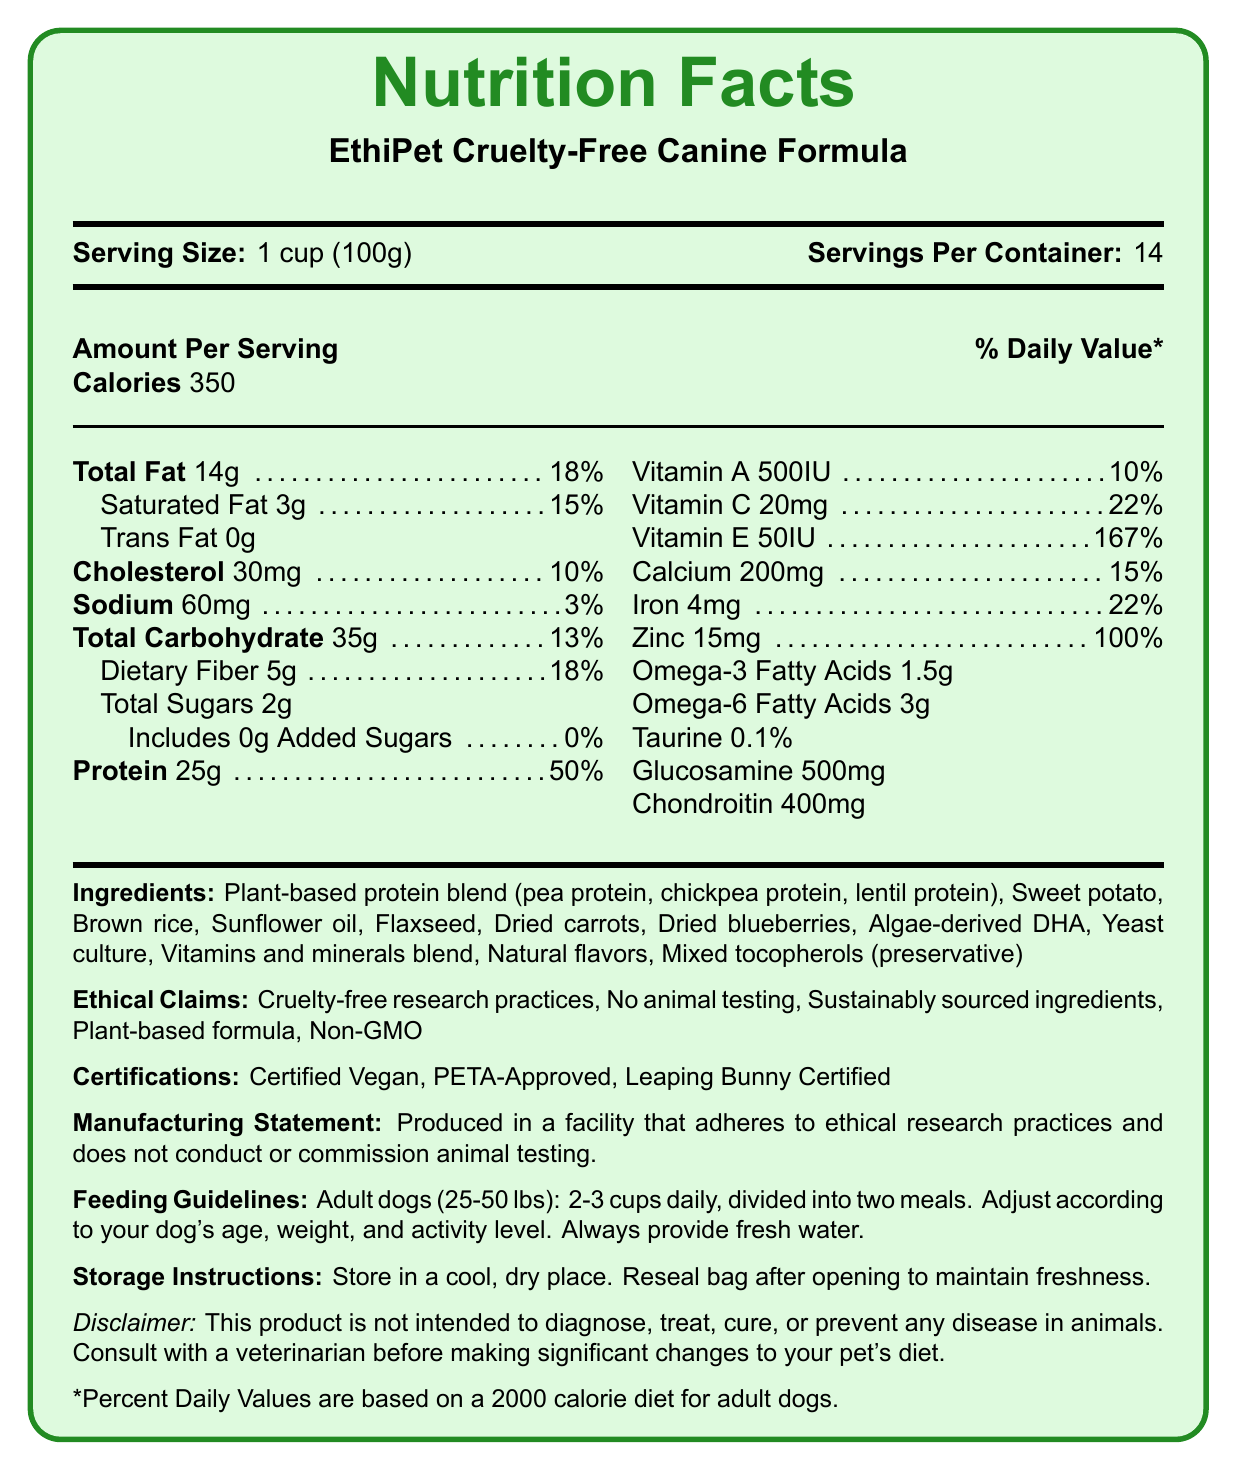what is the serving size for EthiPet Cruelty-Free Canine Formula? The document states that the serving size is 1 cup, which equals 100 grams.
Answer: 1 cup (100g) how many servings are there per container? The document specifies that there are 14 servings per container.
Answer: 14 what are the total calories per serving? The document lists the calories per serving as 350.
Answer: 350 what is the percentage of Daily Value for protein? The document indicates that the protein Daily Value percentage is 50%.
Answer: 50% what are the main ingredients of the product? The ingredients are listed in the document under the "Ingredients" section.
Answer: Plant-based protein blend, Sweet potato, Brown rice, Sunflower oil, Flaxseed, Dried carrots, Dried blueberries, Algae-derived DHA, Yeast culture, Vitamins and minerals blend, Natural flavors, Mixed tocopherols Which of the following are part of the ethical claims made by EthiPet Cruelty-Free Canine Formula? A. Cruelty-free research practices B. No animal testing C. Organic ingredients D. Sustainably sourced ingredients The document lists the ethical claims as: Cruelty-free research practices, No animal testing, Sustainably sourced ingredients, Plant-based formula, Non-GMO. Organic ingredients are not mentioned.
Answer: C. Organic ingredients How much Vitamin C does one serving provide? A. 10mg B. 15mg C. 20mg D. 25mg The document states that the Vitamin C content per serving is 20mg.
Answer: C. 20mg Is the product PETA-Approved? The document lists PETA-Approved under the certifications section.
Answer: Yes What does the document say regarding feeding guidelines for adult dogs? The feeding guidelines section in the document provides this information.
Answer: Adult dogs (25-50 lbs): 2-3 cups daily, divided into two meals. Adjust according to your dog's age, weight, and activity level. Always provide fresh water. Summarize the document. The document provides comprehensive information about the ingredients, nutritional content, ethical certifications, and usage instructions for EthiPet Cruelty-Free Canine Formula, an ethically produced pet food.
Answer: The document presents the nutritional details for EthiPet Cruelty-Free Canine Formula, highlighting serving size, servings per container, calories, and the amounts of various nutrients. It also specifies the ingredients, all of which are plant-based, and mentions several ethical claims and certifications supporting cruelty-free research practices. Additionally, it includes feeding and storage guidelines, along with a disclaimer advising consultation with a veterinarian before changing a pet’s diet. What is the ratio of Omega-3 fatty acids to Omega-6 fatty acids? The document lists 1.5g of Omega-3 fatty acids and 3g of Omega-6 fatty acids per serving, giving a ratio of 1:2.
Answer: 1:2 Does the document list the amount of Vitamin B12 in the product? The document does not provide information on the amount of Vitamin B12 content.
Answer: Not enough information 